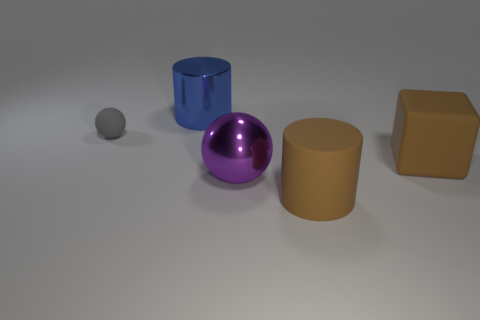Add 3 gray spheres. How many objects exist? 8 Subtract all blocks. How many objects are left? 4 Add 5 small yellow objects. How many small yellow objects exist? 5 Subtract 0 blue cubes. How many objects are left? 5 Subtract all green blocks. Subtract all big brown cylinders. How many objects are left? 4 Add 4 large objects. How many large objects are left? 8 